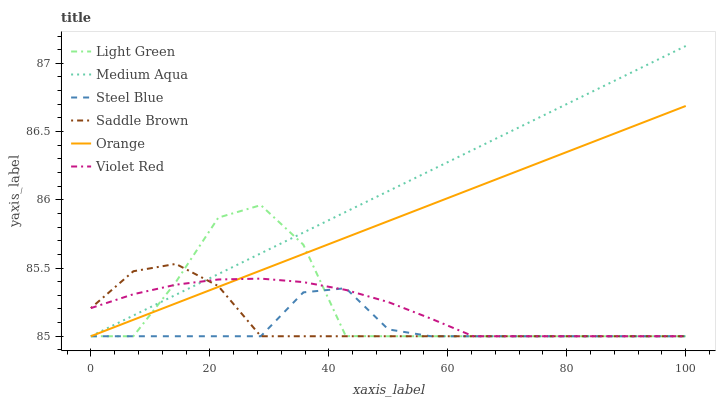Does Medium Aqua have the minimum area under the curve?
Answer yes or no. No. Does Steel Blue have the maximum area under the curve?
Answer yes or no. No. Is Steel Blue the smoothest?
Answer yes or no. No. Is Steel Blue the roughest?
Answer yes or no. No. Does Steel Blue have the highest value?
Answer yes or no. No. 